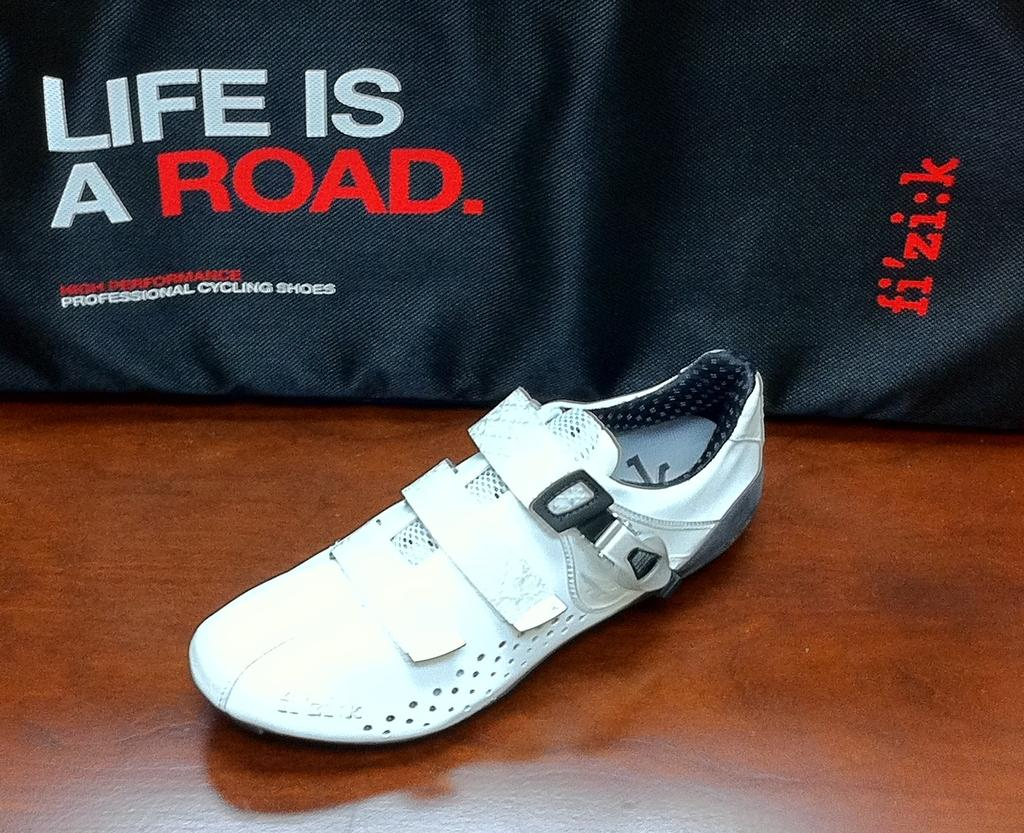What type of shoe is visible in the image? There is a white shoe in the image. What other object is present in the image? There is a black cloth in the image. What can be found on the black cloth? A quotation is written on the black cloth. How much sugar is in the white shoe in the image? There is no sugar present in the white shoe or the image. How many men are depicted on the black cloth in the image? There are no men depicted on the black cloth or in the image. 